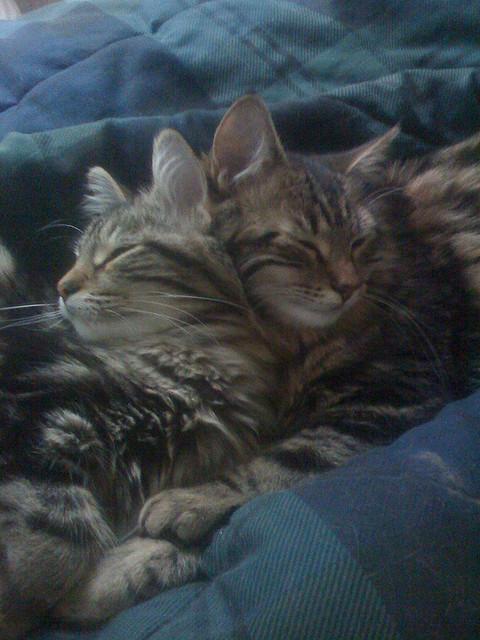Are the cat's eyes closed?
Write a very short answer. Yes. Are the animals the same color?
Answer briefly. Yes. How many animals are shown?
Concise answer only. 2. Is the cat smiling?
Be succinct. No. What animals are they?
Answer briefly. Cats. The eyes are open?
Keep it brief. No. Are these cats content?
Concise answer only. Yes. What color is the blanket?
Concise answer only. Blue. Are the cat's eyes open?
Short answer required. No. Are these dog or cats?
Short answer required. Cats. How many cats are laying down?
Quick response, please. 2. How many cats are sleeping next to each other?
Give a very brief answer. 2. 